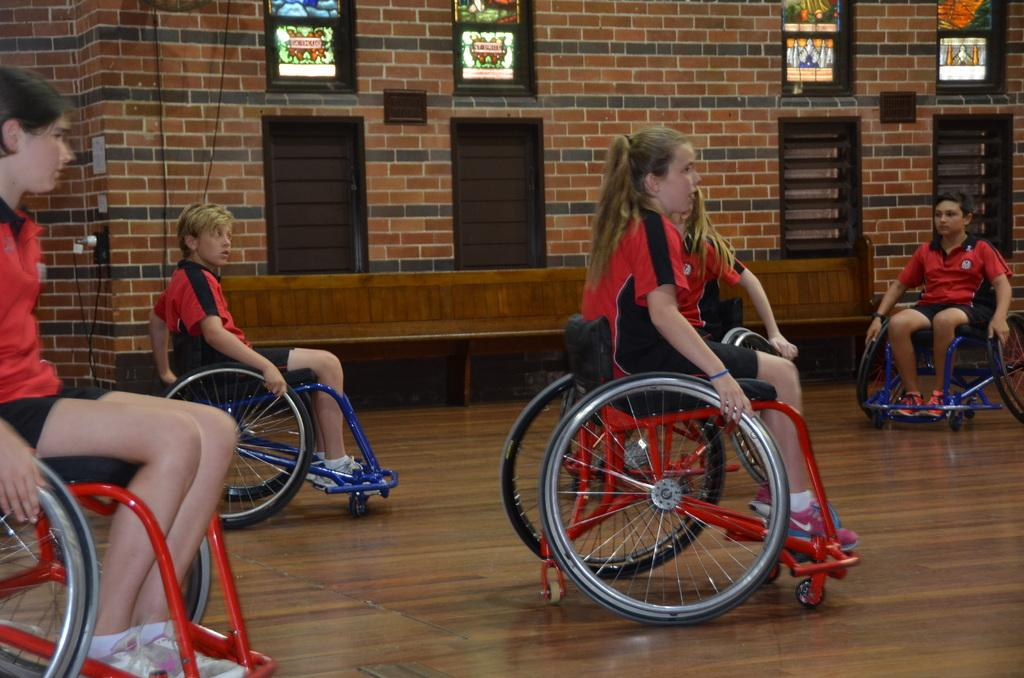What are the people in the image doing? The people in the image are riding vehicles. What can be seen in the background of the image? There is a wall in the image. Are there any openings in the wall? Yes, there are windows in the image. How many oranges are being carried by the frogs in the image? There are no oranges or frogs present in the image. What season is depicted in the image? The provided facts do not mention any seasonal details, so it cannot be determined from the image. 